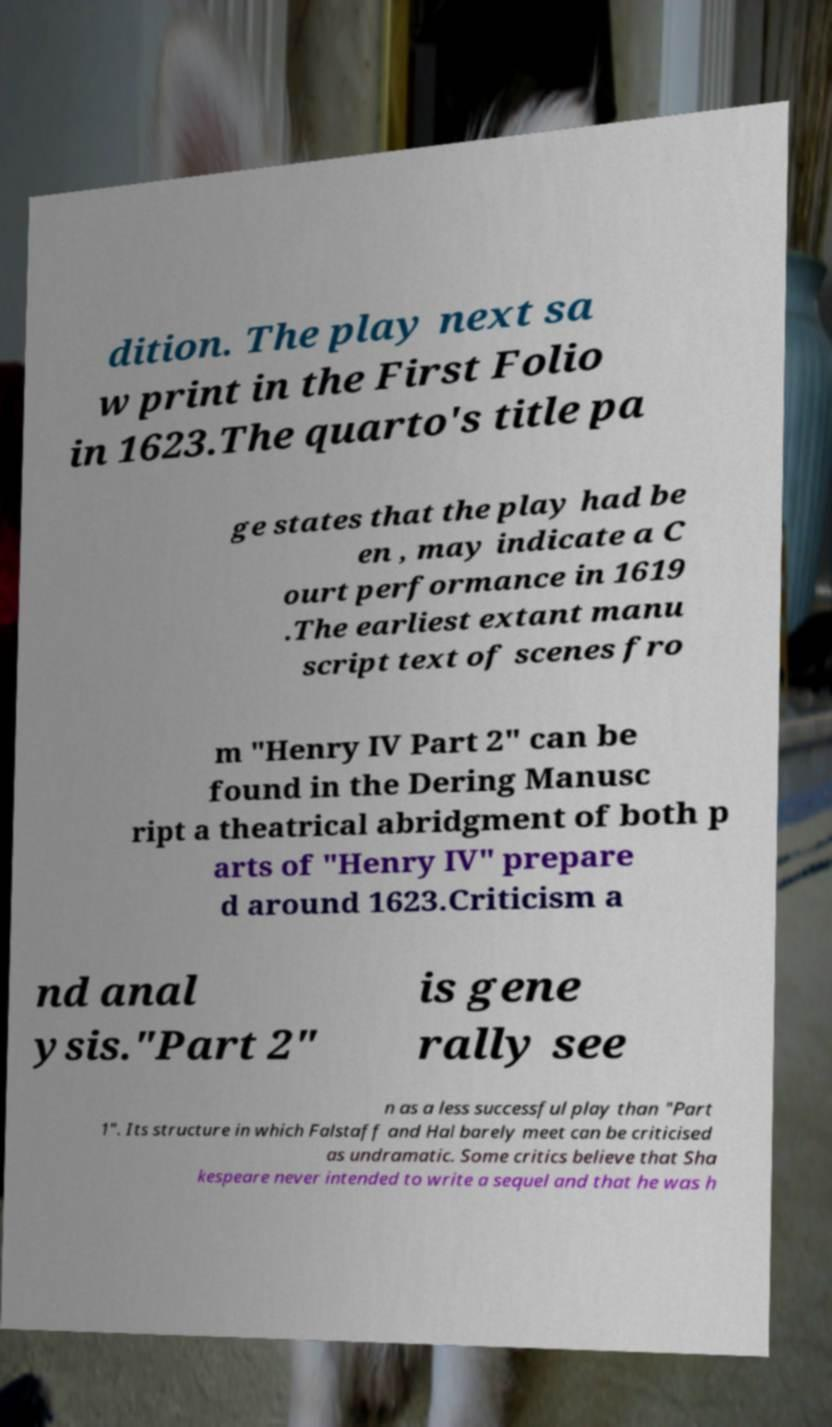Can you read and provide the text displayed in the image?This photo seems to have some interesting text. Can you extract and type it out for me? dition. The play next sa w print in the First Folio in 1623.The quarto's title pa ge states that the play had be en , may indicate a C ourt performance in 1619 .The earliest extant manu script text of scenes fro m "Henry IV Part 2" can be found in the Dering Manusc ript a theatrical abridgment of both p arts of "Henry IV" prepare d around 1623.Criticism a nd anal ysis."Part 2" is gene rally see n as a less successful play than "Part 1". Its structure in which Falstaff and Hal barely meet can be criticised as undramatic. Some critics believe that Sha kespeare never intended to write a sequel and that he was h 